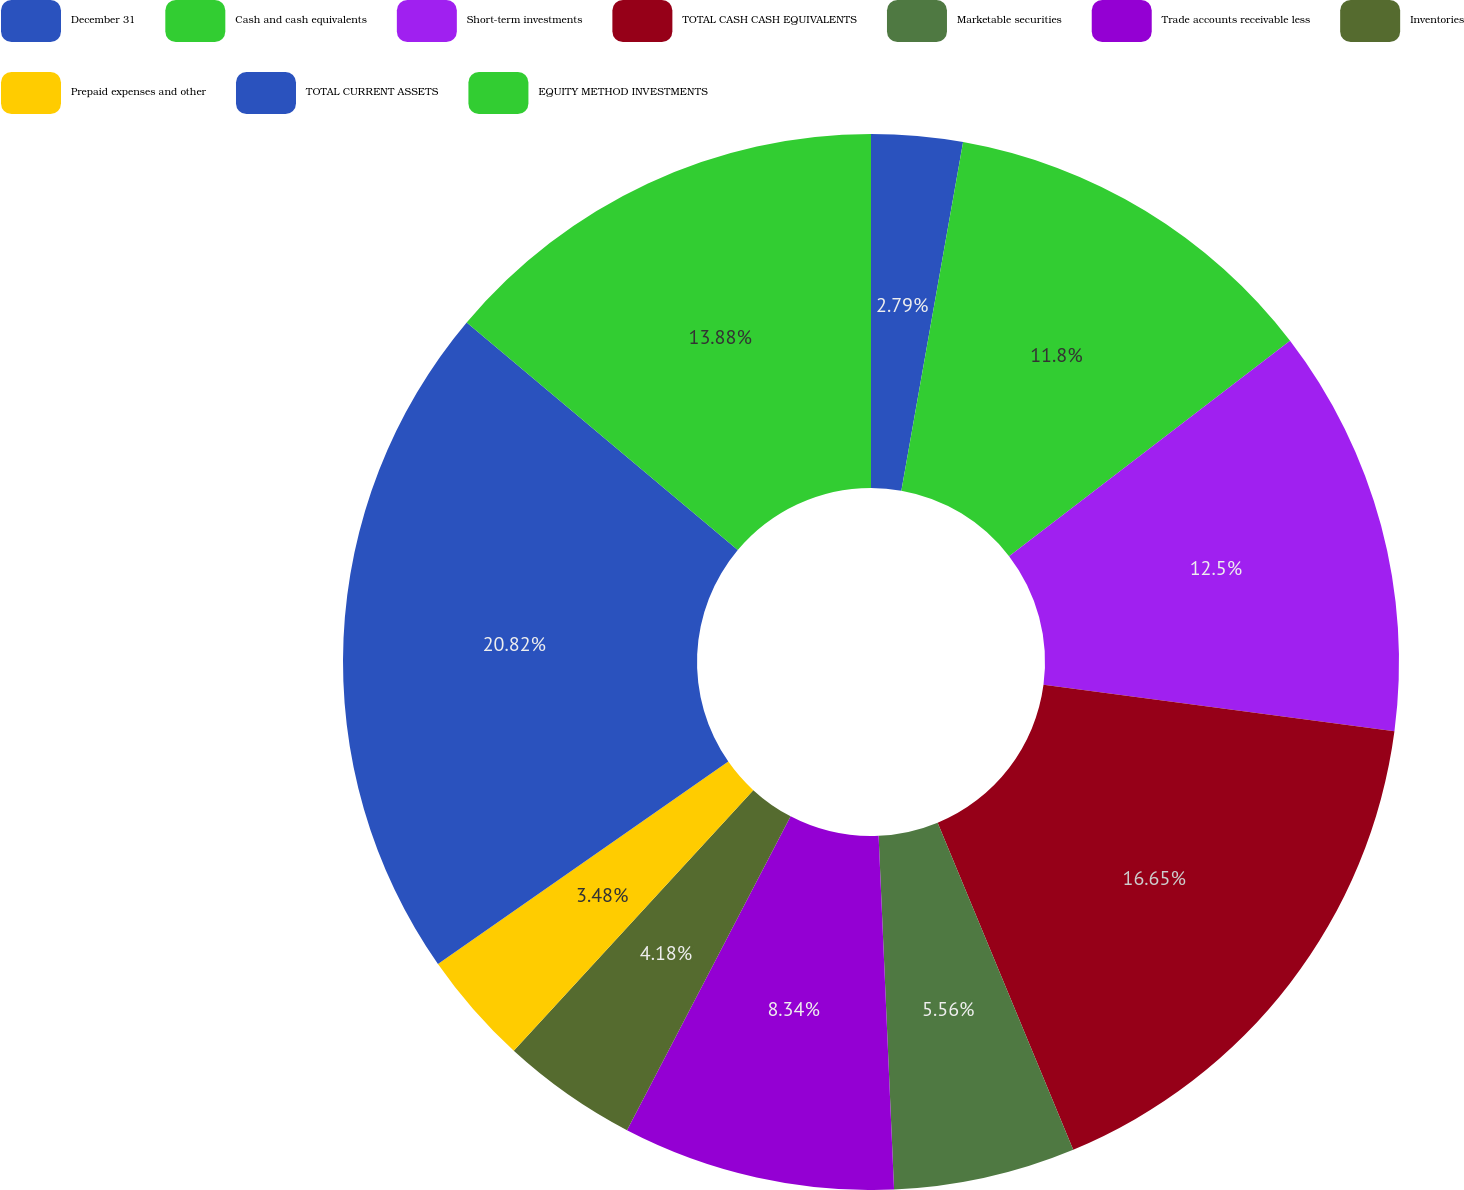Convert chart. <chart><loc_0><loc_0><loc_500><loc_500><pie_chart><fcel>December 31<fcel>Cash and cash equivalents<fcel>Short-term investments<fcel>TOTAL CASH CASH EQUIVALENTS<fcel>Marketable securities<fcel>Trade accounts receivable less<fcel>Inventories<fcel>Prepaid expenses and other<fcel>TOTAL CURRENT ASSETS<fcel>EQUITY METHOD INVESTMENTS<nl><fcel>2.79%<fcel>11.8%<fcel>12.5%<fcel>16.65%<fcel>5.56%<fcel>8.34%<fcel>4.18%<fcel>3.48%<fcel>20.81%<fcel>13.88%<nl></chart> 